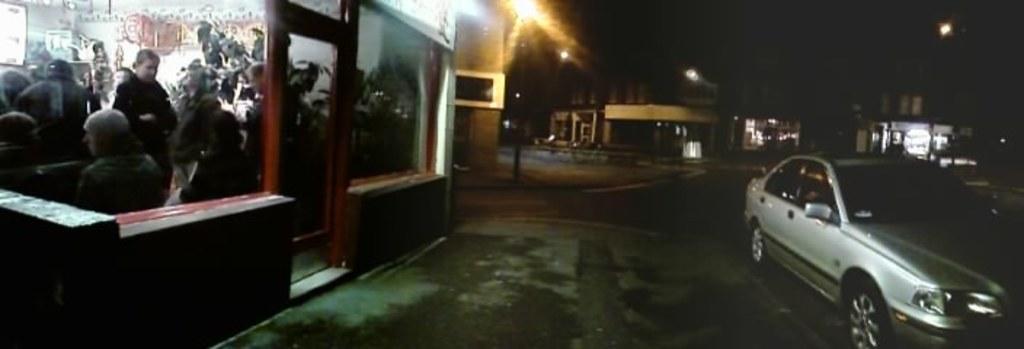Please provide a concise description of this image. This image clicked in the dark. On the right side there is a car on the road. On the left side there are few people inside the cabin. In the background there are some houses and also I can see the light poles. 